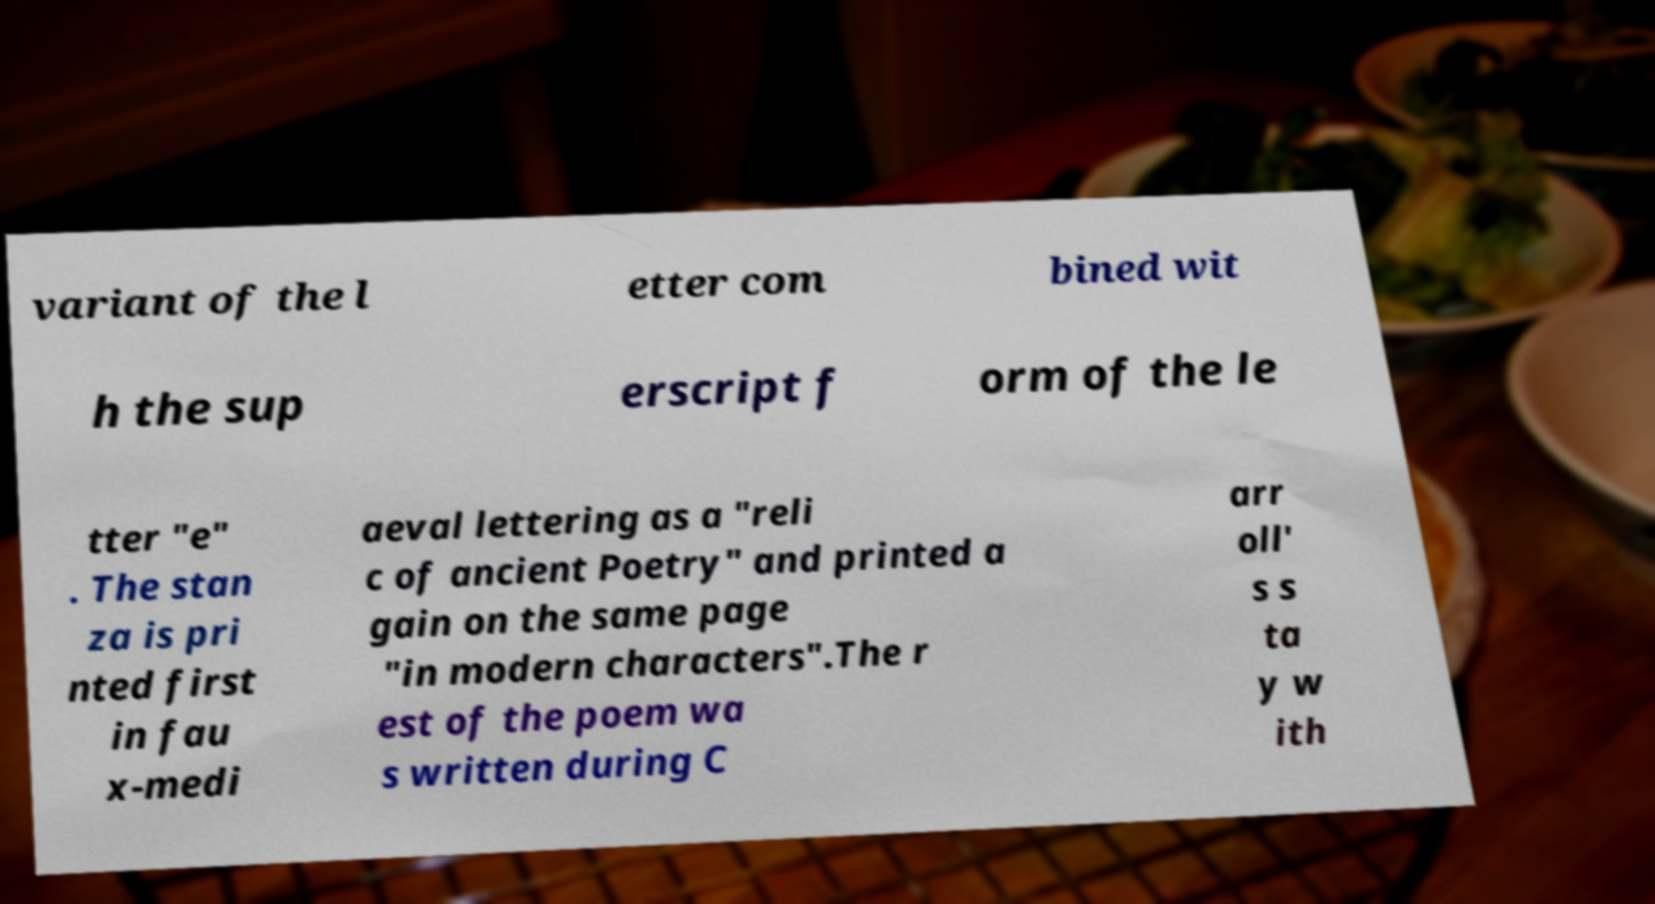For documentation purposes, I need the text within this image transcribed. Could you provide that? variant of the l etter com bined wit h the sup erscript f orm of the le tter "e" . The stan za is pri nted first in fau x-medi aeval lettering as a "reli c of ancient Poetry" and printed a gain on the same page "in modern characters".The r est of the poem wa s written during C arr oll' s s ta y w ith 